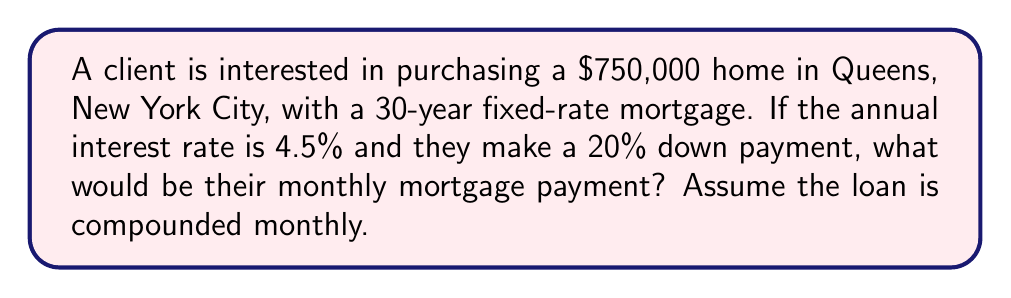Give your solution to this math problem. Let's break this down step-by-step:

1) First, calculate the loan amount:
   Down payment = $750,000 * 20% = $150,000
   Loan amount = $750,000 - $150,000 = $600,000

2) Convert the annual interest rate to monthly:
   Monthly rate = 4.5% / 12 = 0.375% = 0.00375

3) Calculate the number of monthly payments:
   30 years * 12 months/year = 360 payments

4) Use the monthly mortgage payment formula:
   $$P = L \frac{r(1+r)^n}{(1+r)^n-1}$$
   Where:
   $P$ = monthly payment
   $L$ = loan amount
   $r$ = monthly interest rate
   $n$ = number of payments

5) Plug in the values:
   $$P = 600000 \frac{0.00375(1+0.00375)^{360}}{(1+0.00375)^{360}-1}$$

6) Calculate:
   $$P = 600000 \frac{0.00375(1.00375)^{360}}{(1.00375)^{360}-1}$$
   $$P = 600000 \frac{0.00375 * 3.7949}{3.7949 - 1}$$
   $$P = 600000 * 0.00506$$
   $$P = 3036.00$$

Therefore, the monthly mortgage payment would be $3,036.00.
Answer: $3,036.00 